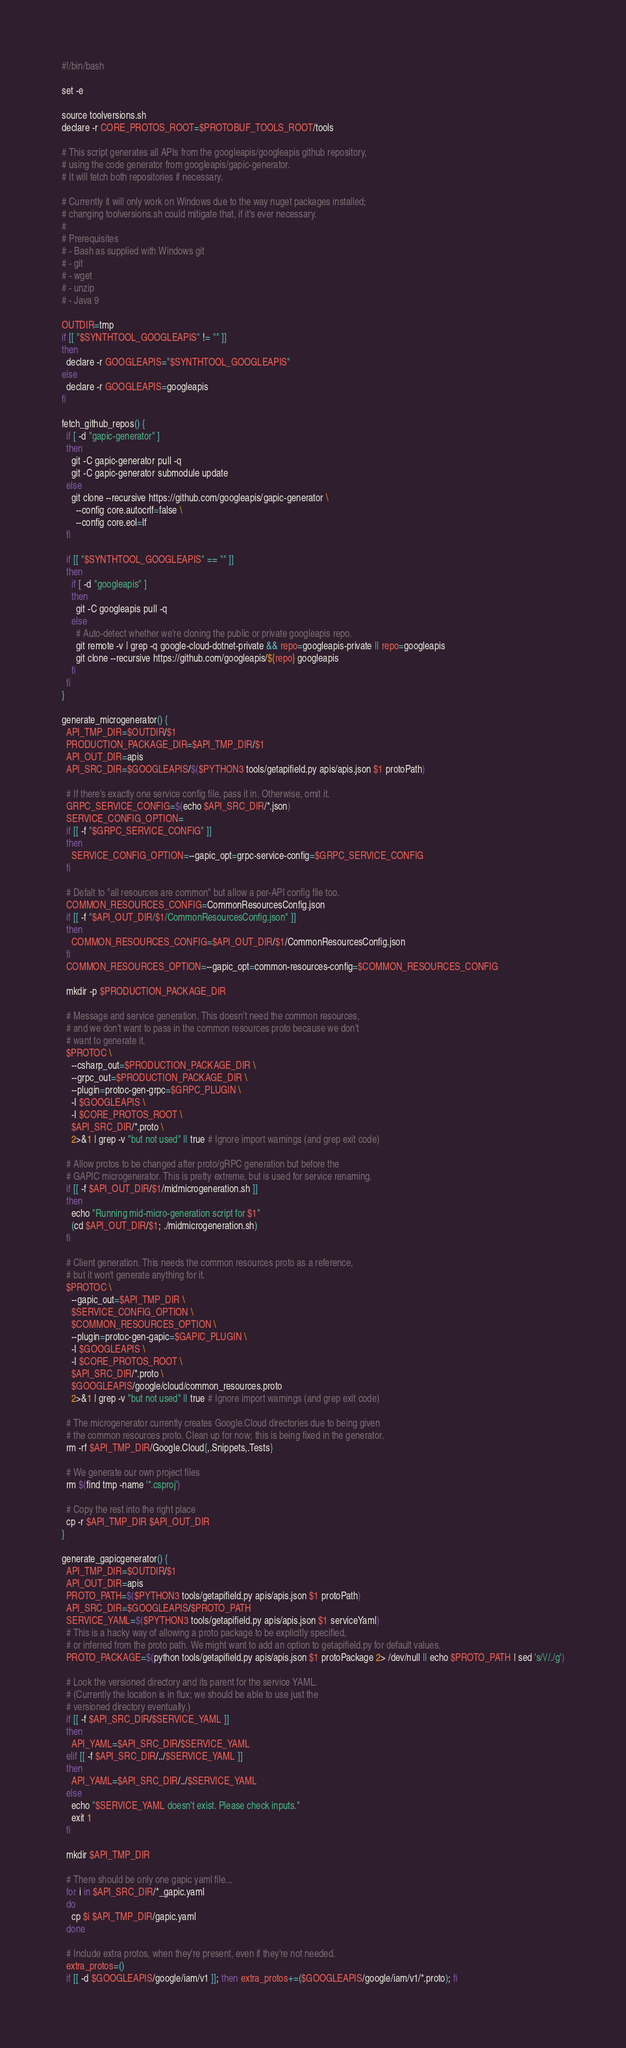<code> <loc_0><loc_0><loc_500><loc_500><_Bash_>#!/bin/bash

set -e

source toolversions.sh
declare -r CORE_PROTOS_ROOT=$PROTOBUF_TOOLS_ROOT/tools

# This script generates all APIs from the googleapis/googleapis github repository,
# using the code generator from googleapis/gapic-generator.
# It will fetch both repositories if necessary.

# Currently it will only work on Windows due to the way nuget packages installed;
# changing toolversions.sh could mitigate that, if it's ever necessary.
#
# Prerequisites
# - Bash as supplied with Windows git
# - git
# - wget
# - unzip
# - Java 9

OUTDIR=tmp
if [[ "$SYNTHTOOL_GOOGLEAPIS" != "" ]]
then
  declare -r GOOGLEAPIS="$SYNTHTOOL_GOOGLEAPIS"
else
  declare -r GOOGLEAPIS=googleapis
fi

fetch_github_repos() {
  if [ -d "gapic-generator" ]
  then
    git -C gapic-generator pull -q
    git -C gapic-generator submodule update
  else
    git clone --recursive https://github.com/googleapis/gapic-generator \
      --config core.autocrlf=false \
      --config core.eol=lf
  fi
          
  if [[ "$SYNTHTOOL_GOOGLEAPIS" == "" ]]
  then
    if [ -d "googleapis" ]
    then
      git -C googleapis pull -q
    else
      # Auto-detect whether we're cloning the public or private googleapis repo.
      git remote -v | grep -q google-cloud-dotnet-private && repo=googleapis-private || repo=googleapis
      git clone --recursive https://github.com/googleapis/${repo} googleapis
    fi
  fi
}

generate_microgenerator() {
  API_TMP_DIR=$OUTDIR/$1
  PRODUCTION_PACKAGE_DIR=$API_TMP_DIR/$1
  API_OUT_DIR=apis
  API_SRC_DIR=$GOOGLEAPIS/$($PYTHON3 tools/getapifield.py apis/apis.json $1 protoPath)

  # If there's exactly one service config file, pass it in. Otherwise, omit it.
  GRPC_SERVICE_CONFIG=$(echo $API_SRC_DIR/*.json)
  SERVICE_CONFIG_OPTION=
  if [[ -f "$GRPC_SERVICE_CONFIG" ]]
  then
    SERVICE_CONFIG_OPTION=--gapic_opt=grpc-service-config=$GRPC_SERVICE_CONFIG
  fi

  # Defalt to "all resources are common" but allow a per-API config file too.
  COMMON_RESOURCES_CONFIG=CommonResourcesConfig.json
  if [[ -f "$API_OUT_DIR/$1/CommonResourcesConfig.json" ]]
  then
    COMMON_RESOURCES_CONFIG=$API_OUT_DIR/$1/CommonResourcesConfig.json
  fi
  COMMON_RESOURCES_OPTION=--gapic_opt=common-resources-config=$COMMON_RESOURCES_CONFIG
  
  mkdir -p $PRODUCTION_PACKAGE_DIR
  
  # Message and service generation. This doesn't need the common resources,
  # and we don't want to pass in the common resources proto because we don't
  # want to generate it.
  $PROTOC \
    --csharp_out=$PRODUCTION_PACKAGE_DIR \
    --grpc_out=$PRODUCTION_PACKAGE_DIR \
    --plugin=protoc-gen-grpc=$GRPC_PLUGIN \
    -I $GOOGLEAPIS \
    -I $CORE_PROTOS_ROOT \
    $API_SRC_DIR/*.proto \
    2>&1 | grep -v "but not used" || true # Ignore import warnings (and grep exit code)

  # Allow protos to be changed after proto/gRPC generation but before the
  # GAPIC microgenerator. This is pretty extreme, but is used for service renaming.
  if [[ -f $API_OUT_DIR/$1/midmicrogeneration.sh ]]
  then
    echo "Running mid-micro-generation script for $1"
    (cd $API_OUT_DIR/$1; ./midmicrogeneration.sh)
  fi

  # Client generation. This needs the common resources proto as a reference,
  # but it won't generate anything for it.
  $PROTOC \
    --gapic_out=$API_TMP_DIR \
    $SERVICE_CONFIG_OPTION \
    $COMMON_RESOURCES_OPTION \
    --plugin=protoc-gen-gapic=$GAPIC_PLUGIN \
    -I $GOOGLEAPIS \
    -I $CORE_PROTOS_ROOT \
    $API_SRC_DIR/*.proto \
    $GOOGLEAPIS/google/cloud/common_resources.proto
    2>&1 | grep -v "but not used" || true # Ignore import warnings (and grep exit code)

  # The microgenerator currently creates Google.Cloud directories due to being given
  # the common resources proto. Clean up for now; this is being fixed in the generator.
  rm -rf $API_TMP_DIR/Google.Cloud{,.Snippets,.Tests}

  # We generate our own project files
  rm $(find tmp -name '*.csproj')
  
  # Copy the rest into the right place
  cp -r $API_TMP_DIR $API_OUT_DIR
}

generate_gapicgenerator() {
  API_TMP_DIR=$OUTDIR/$1
  API_OUT_DIR=apis
  PROTO_PATH=$($PYTHON3 tools/getapifield.py apis/apis.json $1 protoPath)
  API_SRC_DIR=$GOOGLEAPIS/$PROTO_PATH
  SERVICE_YAML=$($PYTHON3 tools/getapifield.py apis/apis.json $1 serviceYaml)
  # This is a hacky way of allowing a proto package to be explicitly specified,
  # or inferred from the proto path. We might want to add an option to getapifield.py for default values.
  PROTO_PACKAGE=$(python tools/getapifield.py apis/apis.json $1 protoPackage 2> /dev/null || echo $PROTO_PATH | sed 's/\//./g')

  # Look the versioned directory and its parent for the service YAML.
  # (Currently the location is in flux; we should be able to use just the
  # versioned directory eventually.)
  if [[ -f $API_SRC_DIR/$SERVICE_YAML ]]
  then
    API_YAML=$API_SRC_DIR/$SERVICE_YAML
  elif [[ -f $API_SRC_DIR/../$SERVICE_YAML ]]
  then
    API_YAML=$API_SRC_DIR/../$SERVICE_YAML
  else
    echo "$SERVICE_YAML doesn't exist. Please check inputs."
    exit 1
  fi

  mkdir $API_TMP_DIR
  
  # There should be only one gapic yaml file...
  for i in $API_SRC_DIR/*_gapic.yaml
  do
    cp $i $API_TMP_DIR/gapic.yaml
  done
  
  # Include extra protos, when they're present, even if they're not needed.
  extra_protos=()
  if [[ -d $GOOGLEAPIS/google/iam/v1 ]]; then extra_protos+=($GOOGLEAPIS/google/iam/v1/*.proto); fi</code> 